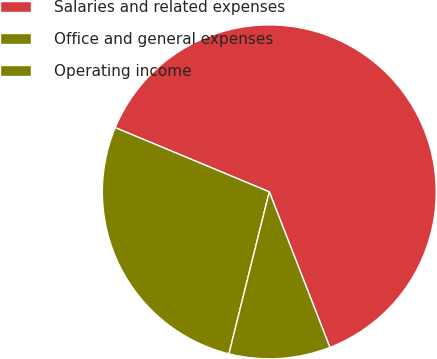<chart> <loc_0><loc_0><loc_500><loc_500><pie_chart><fcel>Salaries and related expenses<fcel>Office and general expenses<fcel>Operating income<nl><fcel>62.8%<fcel>27.4%<fcel>9.8%<nl></chart> 